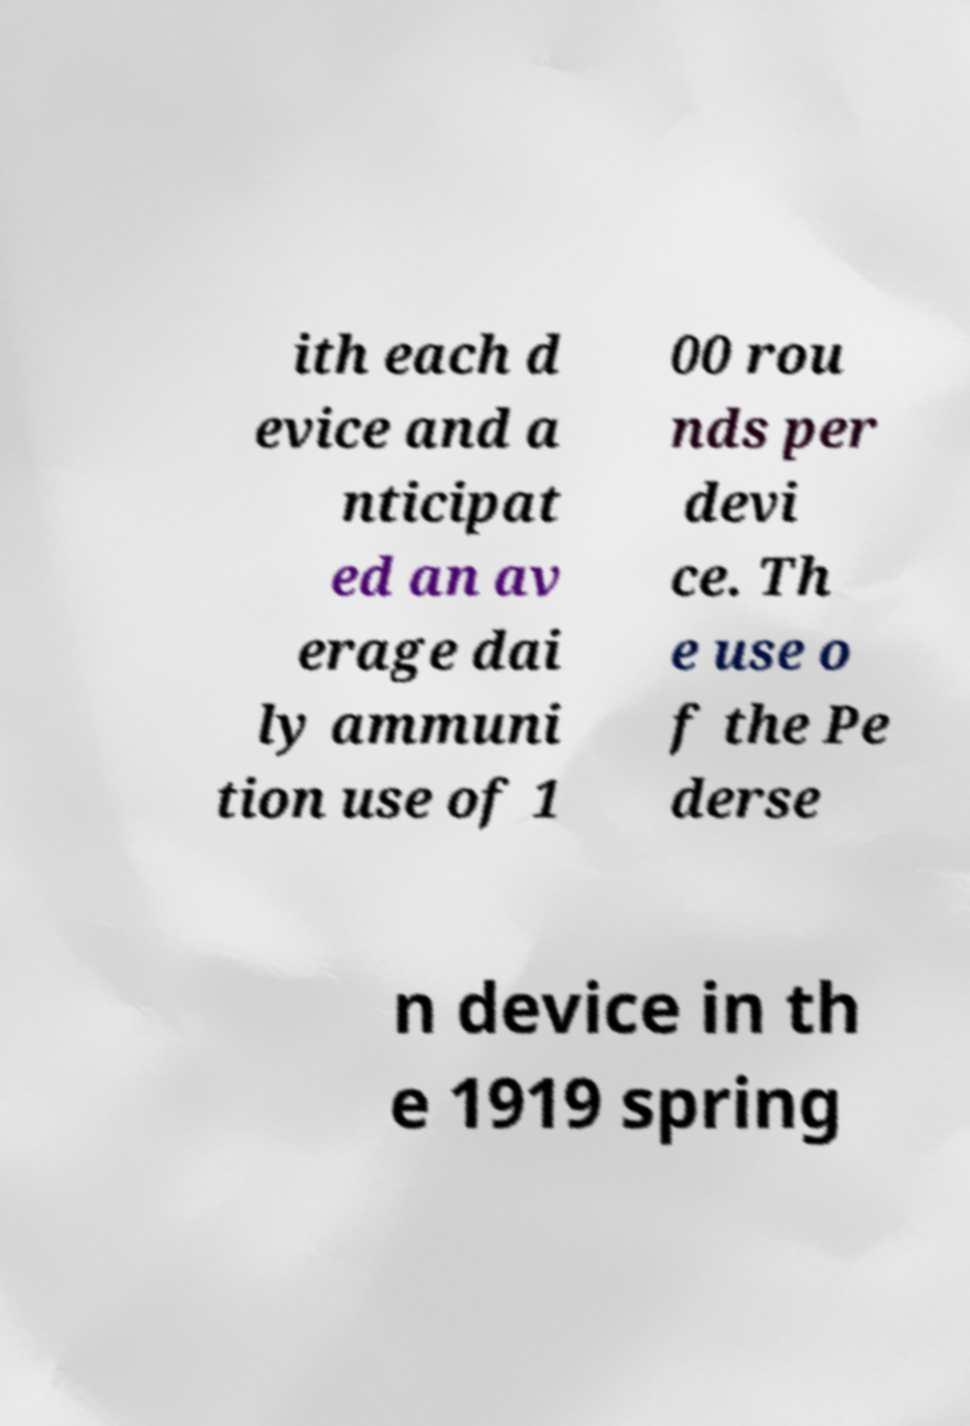Can you accurately transcribe the text from the provided image for me? ith each d evice and a nticipat ed an av erage dai ly ammuni tion use of 1 00 rou nds per devi ce. Th e use o f the Pe derse n device in th e 1919 spring 